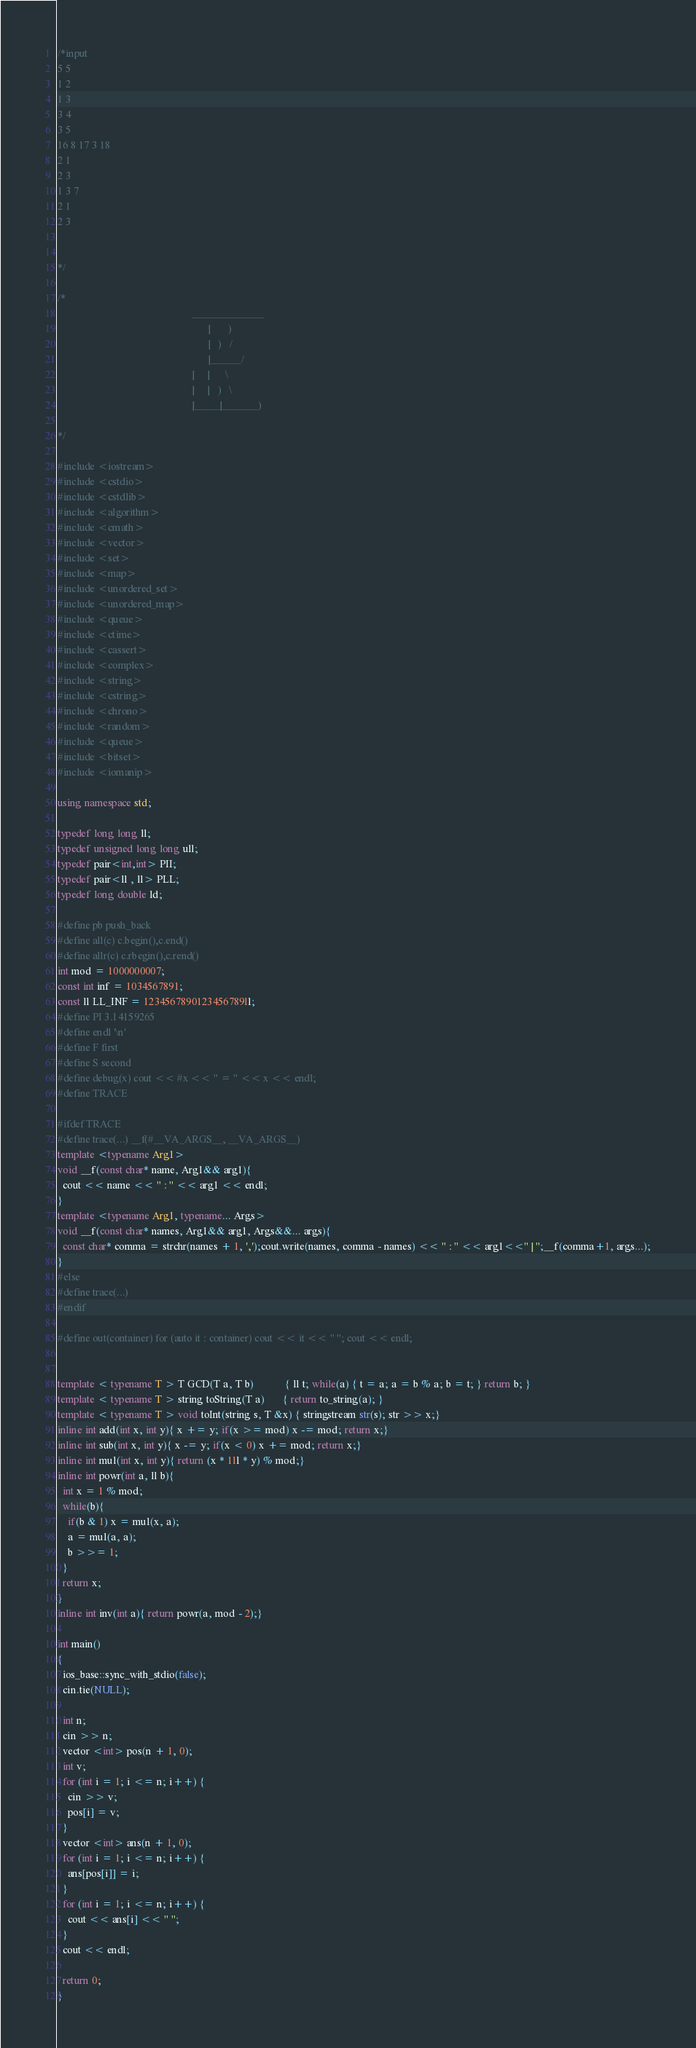Convert code to text. <code><loc_0><loc_0><loc_500><loc_500><_C++_>/*input
5 5
1 2
1 3
3 4
3 5
16 8 17 3 18
2 1
2 3
1 3 7
2 1
2 3


*/
 
/*
                                                    ______________
                                                          |       )
                                                          |   )   /
                                                          |______/
                                                    |     |      \
                                                    |     |   )   \
                                                    |_____|_______)
 
*/
 
#include <iostream>
#include <cstdio>
#include <cstdlib>
#include <algorithm>
#include <cmath>
#include <vector>
#include <set>
#include <map>
#include <unordered_set>
#include <unordered_map>
#include <queue>
#include <ctime>
#include <cassert>
#include <complex>
#include <string>
#include <cstring>
#include <chrono>
#include <random>
#include <queue>
#include <bitset>
#include <iomanip>
 
using namespace std;
 
typedef long long ll;
typedef unsigned long long ull;
typedef pair<int,int> PII;
typedef pair<ll , ll> PLL;
typedef long double ld;
 
#define pb push_back
#define all(c) c.begin(),c.end()
#define allr(c) c.rbegin(),c.rend()
int mod = 1000000007;
const int inf = 1034567891;
const ll LL_INF = 1234567890123456789ll;
#define PI 3.14159265
#define endl '\n'
#define F first
#define S second
#define debug(x) cout << #x << " = " << x << endl;
#define TRACE
 
#ifdef TRACE
#define trace(...) __f(#__VA_ARGS__, __VA_ARGS__)
template <typename Arg1>
void __f(const char* name, Arg1&& arg1){
  cout << name << " : " << arg1 << endl;
}
template <typename Arg1, typename... Args>
void __f(const char* names, Arg1&& arg1, Args&&... args){
  const char* comma = strchr(names + 1, ',');cout.write(names, comma - names) << " : " << arg1<<" | ";__f(comma+1, args...);
}
#else
#define trace(...)
#endif
 
#define out(container) for (auto it : container) cout << it << " "; cout << endl;
 
 
template < typename T > T GCD(T a, T b)            { ll t; while(a) { t = a; a = b % a; b = t; } return b; }
template < typename T > string toString(T a)       { return to_string(a); }
template < typename T > void toInt(string s, T &x) { stringstream str(s); str >> x;}
inline int add(int x, int y){ x += y; if(x >= mod) x -= mod; return x;}
inline int sub(int x, int y){ x -= y; if(x < 0) x += mod; return x;}
inline int mul(int x, int y){ return (x * 1ll * y) % mod;}
inline int powr(int a, ll b){
  int x = 1 % mod;
  while(b){
    if(b & 1) x = mul(x, a);
    a = mul(a, a);
    b >>= 1;
  }
  return x;
}
inline int inv(int a){ return powr(a, mod - 2);}

int main()
{
  ios_base::sync_with_stdio(false);
  cin.tie(NULL);
  
  int n;
  cin >> n;
  vector <int> pos(n + 1, 0);
  int v;
  for (int i = 1; i <= n; i++) {
    cin >> v;
    pos[i] = v;
  }
  vector <int> ans(n + 1, 0);
  for (int i = 1; i <= n; i++) {
    ans[pos[i]] = i;
  }
  for (int i = 1; i <= n; i++) {
    cout << ans[i] << " ";
  }
  cout << endl;

  return 0;
}</code> 